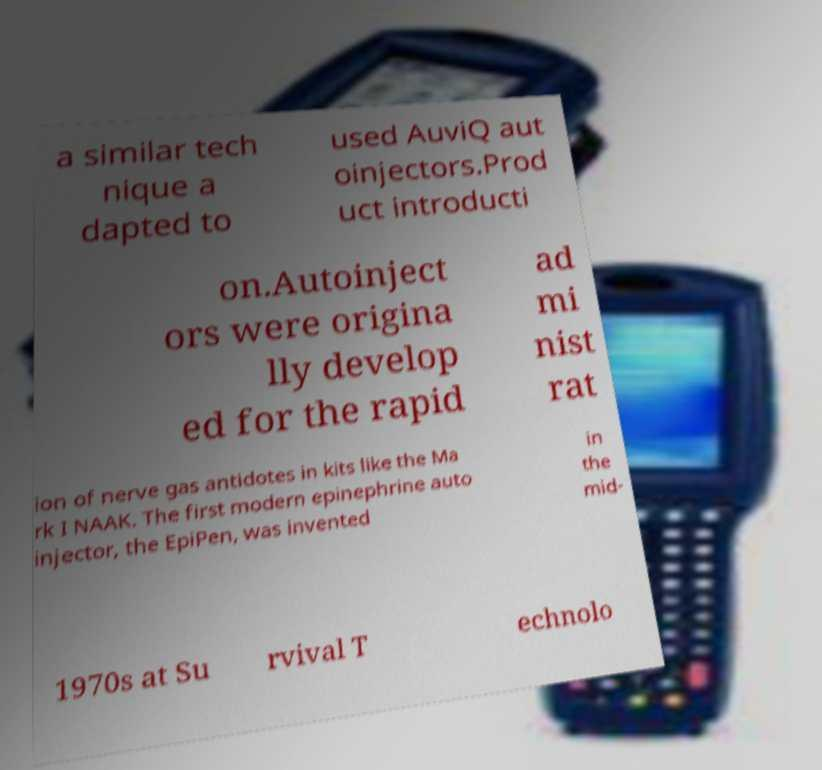I need the written content from this picture converted into text. Can you do that? a similar tech nique a dapted to used AuviQ aut oinjectors.Prod uct introducti on.Autoinject ors were origina lly develop ed for the rapid ad mi nist rat ion of nerve gas antidotes in kits like the Ma rk I NAAK. The first modern epinephrine auto injector, the EpiPen, was invented in the mid- 1970s at Su rvival T echnolo 